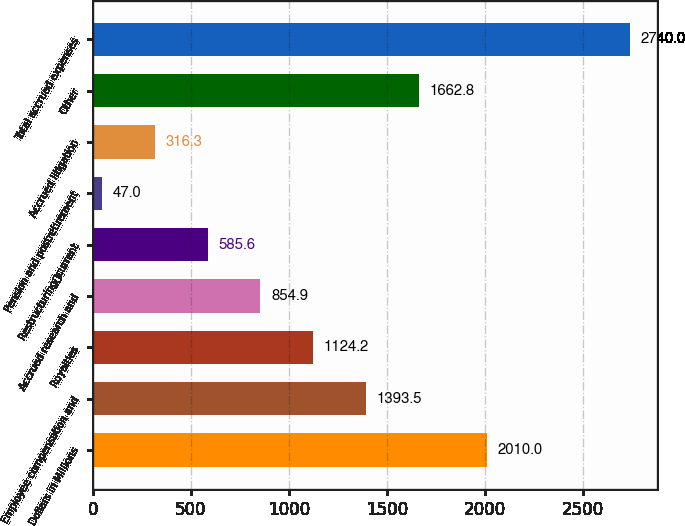Convert chart to OTSL. <chart><loc_0><loc_0><loc_500><loc_500><bar_chart><fcel>Dollars in Millions<fcel>Employee compensation and<fcel>Royalties<fcel>Accrued research and<fcel>Restructuringcurrent<fcel>Pension and postretirement<fcel>Accrued litigation<fcel>Other<fcel>Total accrued expenses<nl><fcel>2010<fcel>1393.5<fcel>1124.2<fcel>854.9<fcel>585.6<fcel>47<fcel>316.3<fcel>1662.8<fcel>2740<nl></chart> 